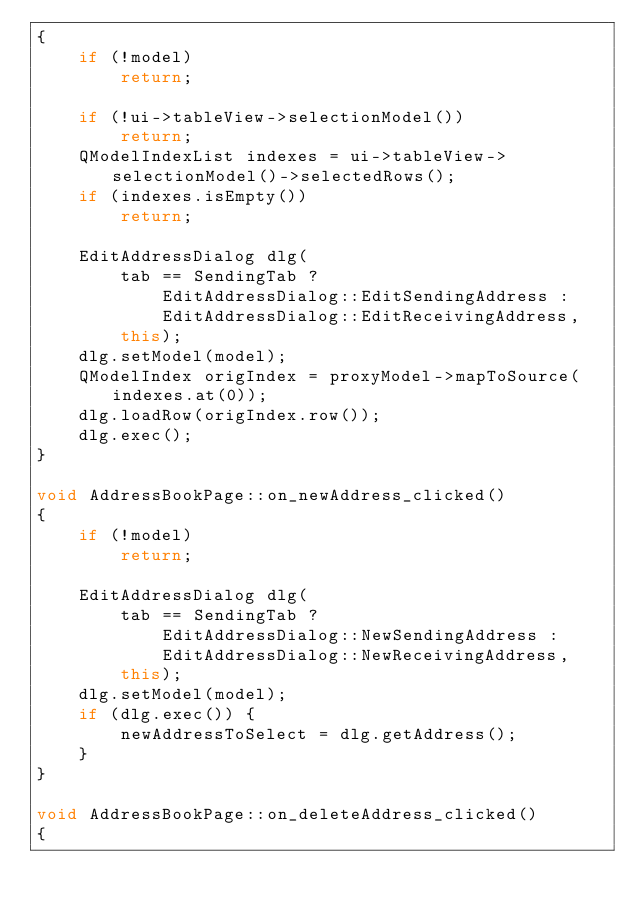<code> <loc_0><loc_0><loc_500><loc_500><_C++_>{
    if (!model)
        return;

    if (!ui->tableView->selectionModel())
        return;
    QModelIndexList indexes = ui->tableView->selectionModel()->selectedRows();
    if (indexes.isEmpty())
        return;

    EditAddressDialog dlg(
        tab == SendingTab ?
            EditAddressDialog::EditSendingAddress :
            EditAddressDialog::EditReceivingAddress,
        this);
    dlg.setModel(model);
    QModelIndex origIndex = proxyModel->mapToSource(indexes.at(0));
    dlg.loadRow(origIndex.row());
    dlg.exec();
}

void AddressBookPage::on_newAddress_clicked()
{
    if (!model)
        return;

    EditAddressDialog dlg(
        tab == SendingTab ?
            EditAddressDialog::NewSendingAddress :
            EditAddressDialog::NewReceivingAddress,
        this);
    dlg.setModel(model);
    if (dlg.exec()) {
        newAddressToSelect = dlg.getAddress();
    }
}

void AddressBookPage::on_deleteAddress_clicked()
{</code> 